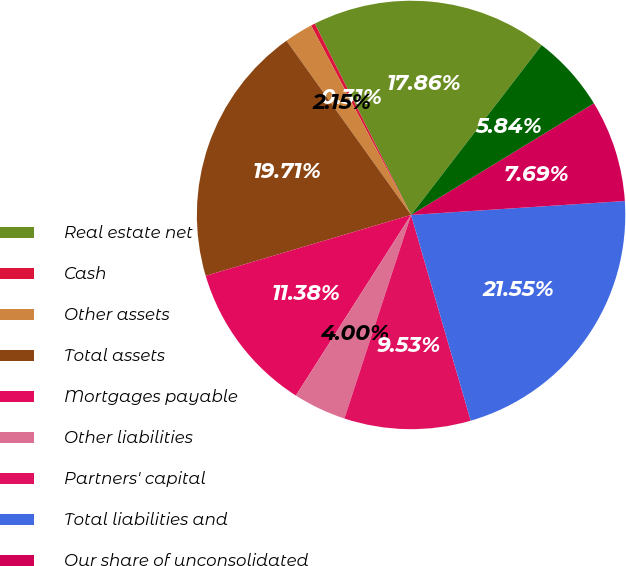Convert chart to OTSL. <chart><loc_0><loc_0><loc_500><loc_500><pie_chart><fcel>Real estate net<fcel>Cash<fcel>Other assets<fcel>Total assets<fcel>Mortgages payable<fcel>Other liabilities<fcel>Partners' capital<fcel>Total liabilities and<fcel>Our share of unconsolidated<fcel>Our investment in real estate<nl><fcel>17.86%<fcel>0.31%<fcel>2.15%<fcel>19.71%<fcel>11.38%<fcel>4.0%<fcel>9.53%<fcel>21.55%<fcel>7.69%<fcel>5.84%<nl></chart> 